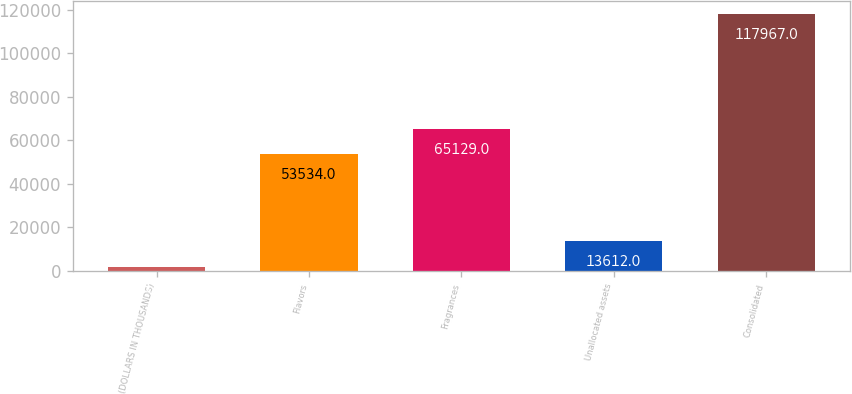Convert chart. <chart><loc_0><loc_0><loc_500><loc_500><bar_chart><fcel>(DOLLARS IN THOUSANDS)<fcel>Flavors<fcel>Fragrances<fcel>Unallocated assets<fcel>Consolidated<nl><fcel>2017<fcel>53534<fcel>65129<fcel>13612<fcel>117967<nl></chart> 